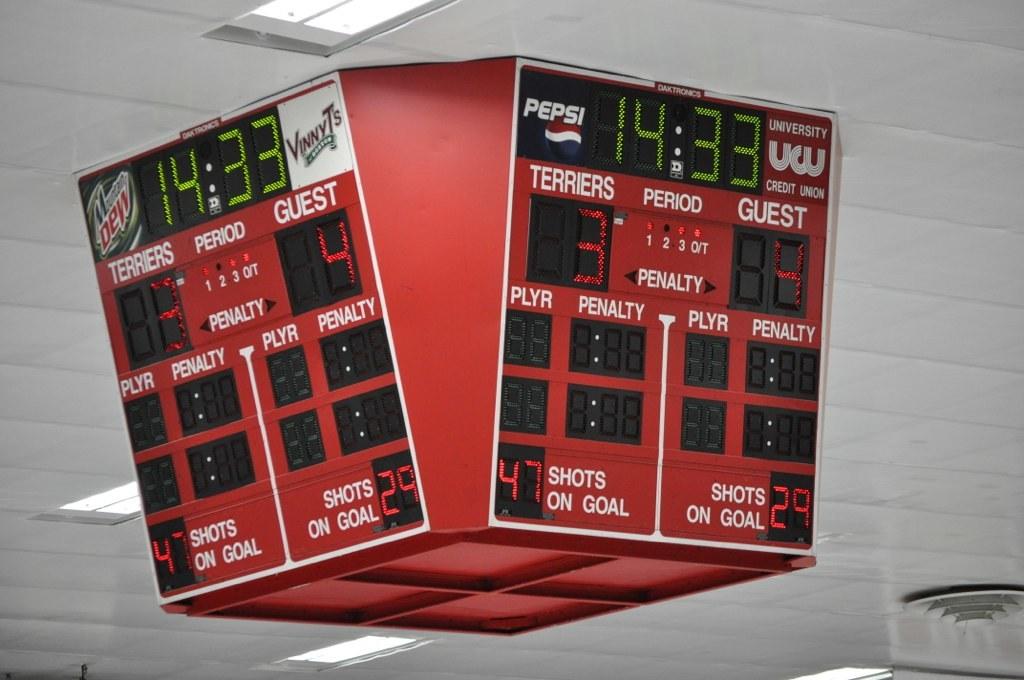What are the scores on the scoreboard?
Provide a short and direct response. 3 and 4. How many shots on goal does the "guest" have?
Your answer should be compact. 29. 